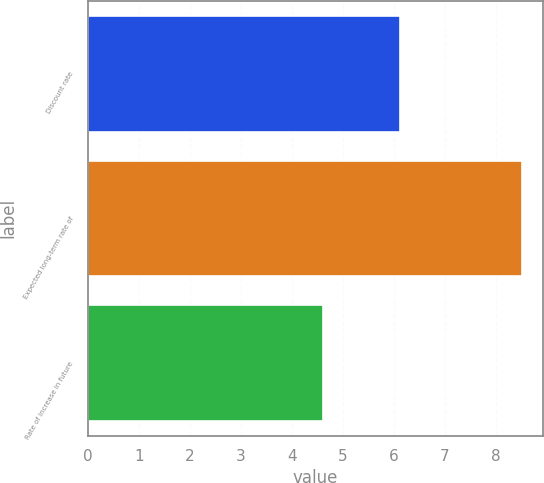<chart> <loc_0><loc_0><loc_500><loc_500><bar_chart><fcel>Discount rate<fcel>Expected long-term rate of<fcel>Rate of increase in future<nl><fcel>6.12<fcel>8.5<fcel>4.6<nl></chart> 